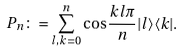Convert formula to latex. <formula><loc_0><loc_0><loc_500><loc_500>P _ { n } \colon = \sum _ { l , k = 0 } ^ { n } \cos \frac { k l \pi } { n } | l \rangle \langle k | .</formula> 